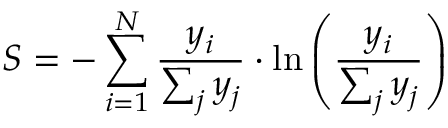Convert formula to latex. <formula><loc_0><loc_0><loc_500><loc_500>S = - \sum _ { i = 1 } ^ { N } \frac { y _ { i } } { \sum _ { j } y _ { j } } \cdot \ln \left ( \frac { y _ { i } } { \sum _ { j } y _ { j } } \right )</formula> 